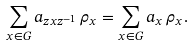Convert formula to latex. <formula><loc_0><loc_0><loc_500><loc_500>\sum _ { x \in G } a _ { z x z ^ { - 1 } } \, \rho _ { x } = \sum _ { x \in G } a _ { x } \, \rho _ { x } .</formula> 